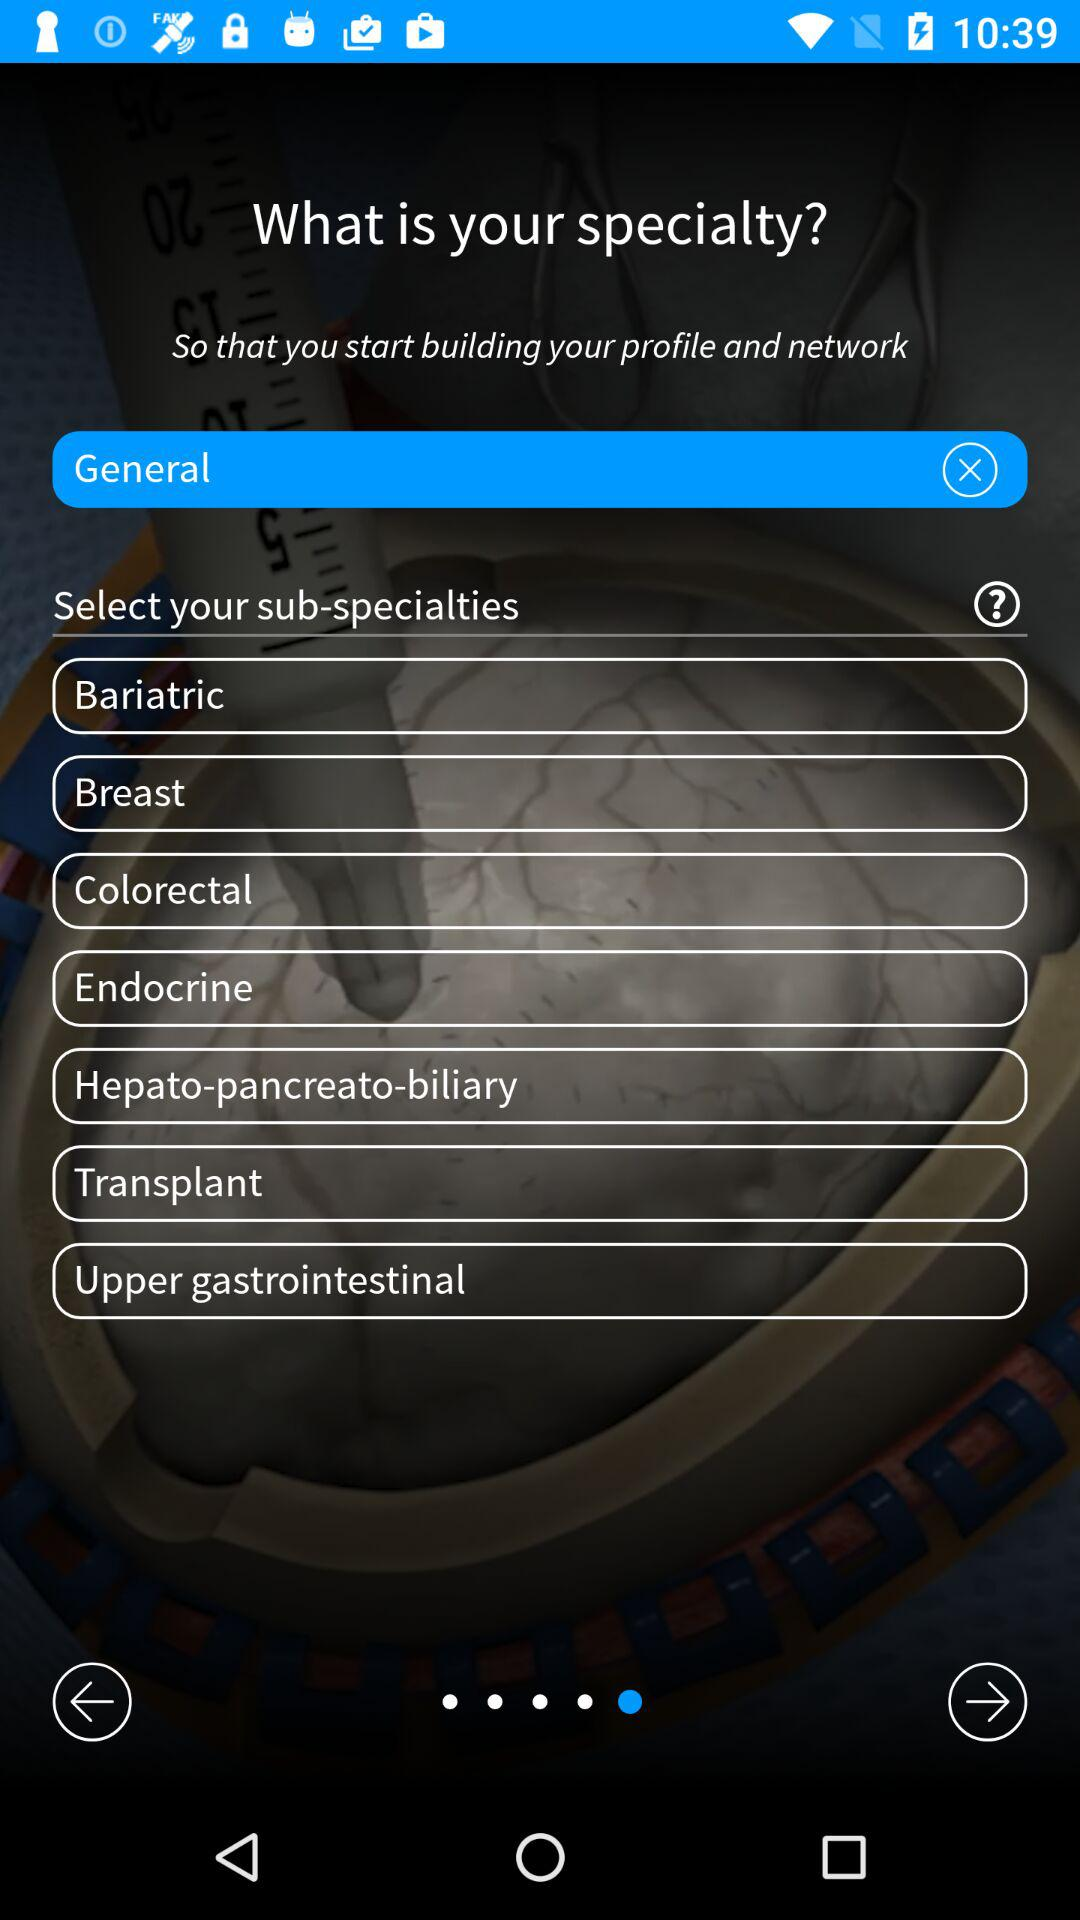What is the selected specialty? The selected specialty is "General". 